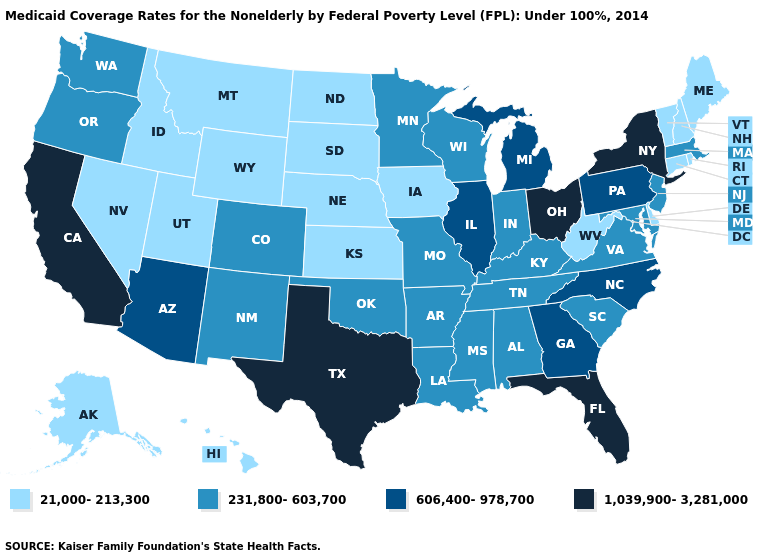Does Delaware have the same value as Virginia?
Concise answer only. No. Among the states that border Virginia , does West Virginia have the lowest value?
Keep it brief. Yes. What is the value of New York?
Be succinct. 1,039,900-3,281,000. Name the states that have a value in the range 606,400-978,700?
Short answer required. Arizona, Georgia, Illinois, Michigan, North Carolina, Pennsylvania. Name the states that have a value in the range 231,800-603,700?
Answer briefly. Alabama, Arkansas, Colorado, Indiana, Kentucky, Louisiana, Maryland, Massachusetts, Minnesota, Mississippi, Missouri, New Jersey, New Mexico, Oklahoma, Oregon, South Carolina, Tennessee, Virginia, Washington, Wisconsin. Does the first symbol in the legend represent the smallest category?
Keep it brief. Yes. Which states have the lowest value in the West?
Write a very short answer. Alaska, Hawaii, Idaho, Montana, Nevada, Utah, Wyoming. Name the states that have a value in the range 1,039,900-3,281,000?
Quick response, please. California, Florida, New York, Ohio, Texas. Does New Hampshire have the lowest value in the USA?
Give a very brief answer. Yes. How many symbols are there in the legend?
Quick response, please. 4. Is the legend a continuous bar?
Write a very short answer. No. Among the states that border Wyoming , which have the lowest value?
Keep it brief. Idaho, Montana, Nebraska, South Dakota, Utah. Is the legend a continuous bar?
Keep it brief. No. Name the states that have a value in the range 21,000-213,300?
Keep it brief. Alaska, Connecticut, Delaware, Hawaii, Idaho, Iowa, Kansas, Maine, Montana, Nebraska, Nevada, New Hampshire, North Dakota, Rhode Island, South Dakota, Utah, Vermont, West Virginia, Wyoming. What is the lowest value in the Northeast?
Short answer required. 21,000-213,300. 